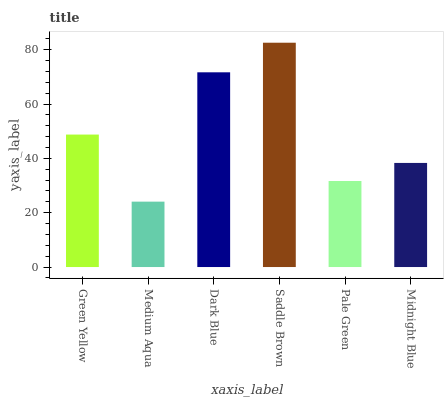Is Dark Blue the minimum?
Answer yes or no. No. Is Dark Blue the maximum?
Answer yes or no. No. Is Dark Blue greater than Medium Aqua?
Answer yes or no. Yes. Is Medium Aqua less than Dark Blue?
Answer yes or no. Yes. Is Medium Aqua greater than Dark Blue?
Answer yes or no. No. Is Dark Blue less than Medium Aqua?
Answer yes or no. No. Is Green Yellow the high median?
Answer yes or no. Yes. Is Midnight Blue the low median?
Answer yes or no. Yes. Is Dark Blue the high median?
Answer yes or no. No. Is Green Yellow the low median?
Answer yes or no. No. 